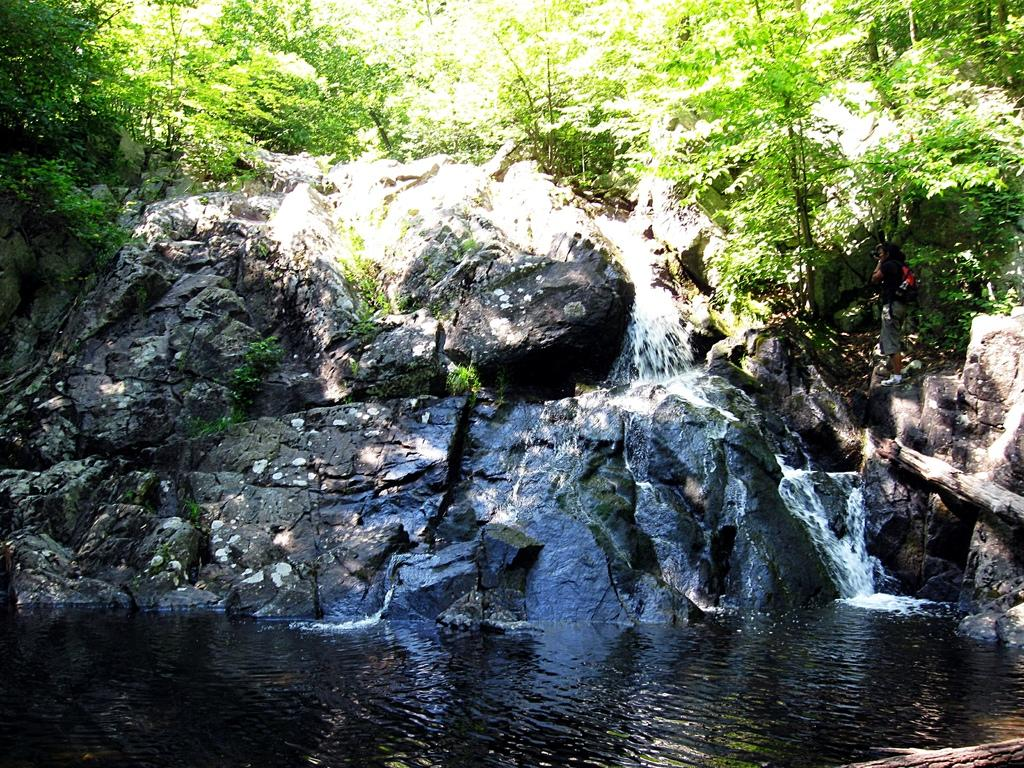What is at the bottom of the image? There is water at the bottom of the image. What can be seen in the middle of the image? There is a hill in the middle of the image. What type of vegetation is on the hill? There are trees on the hill. What is the person in the image doing? There is a person standing on the hill. What type of mask is the person wearing in the image? There is no mask present in the image; the person is simply standing on the hill. What relation does the person have to the trees on the hill? The provided facts do not mention any relation between the person and the trees on the hill. 